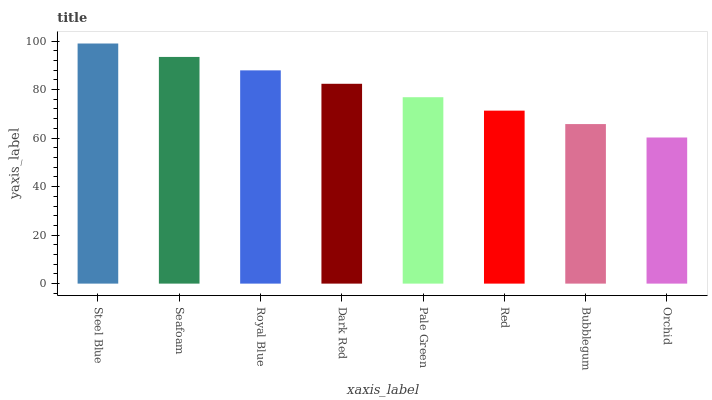Is Orchid the minimum?
Answer yes or no. Yes. Is Steel Blue the maximum?
Answer yes or no. Yes. Is Seafoam the minimum?
Answer yes or no. No. Is Seafoam the maximum?
Answer yes or no. No. Is Steel Blue greater than Seafoam?
Answer yes or no. Yes. Is Seafoam less than Steel Blue?
Answer yes or no. Yes. Is Seafoam greater than Steel Blue?
Answer yes or no. No. Is Steel Blue less than Seafoam?
Answer yes or no. No. Is Dark Red the high median?
Answer yes or no. Yes. Is Pale Green the low median?
Answer yes or no. Yes. Is Pale Green the high median?
Answer yes or no. No. Is Royal Blue the low median?
Answer yes or no. No. 